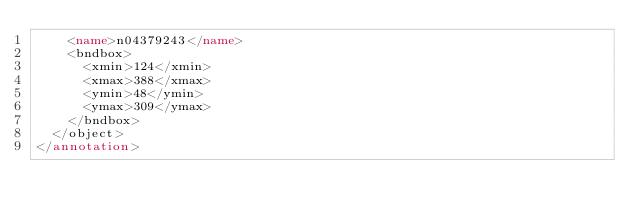<code> <loc_0><loc_0><loc_500><loc_500><_XML_>		<name>n04379243</name>
		<bndbox>
			<xmin>124</xmin>
			<xmax>388</xmax>
			<ymin>48</ymin>
			<ymax>309</ymax>
		</bndbox>
	</object>
</annotation>
</code> 